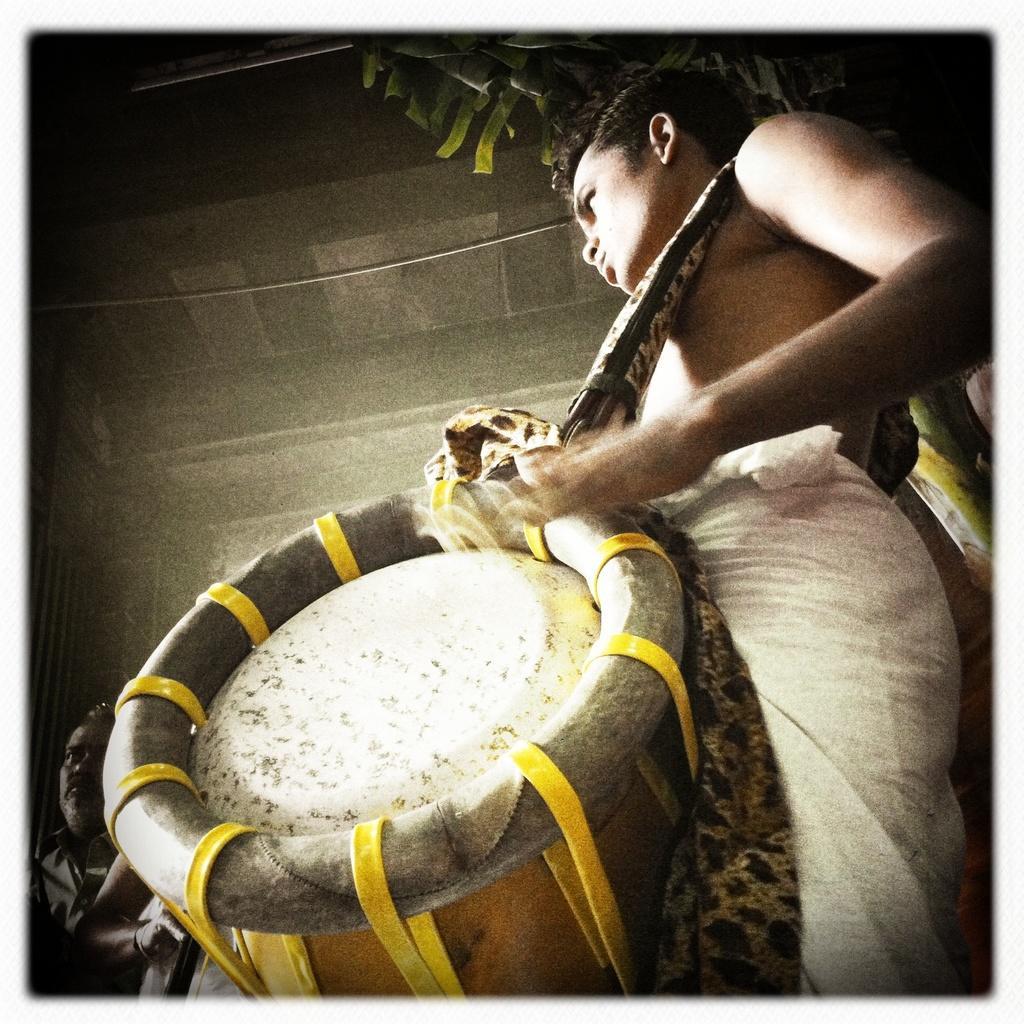Describe this image in one or two sentences. In this picture I can see there is a man standing here and wearing and playing a tabla and in the backdrop there is a wall. 